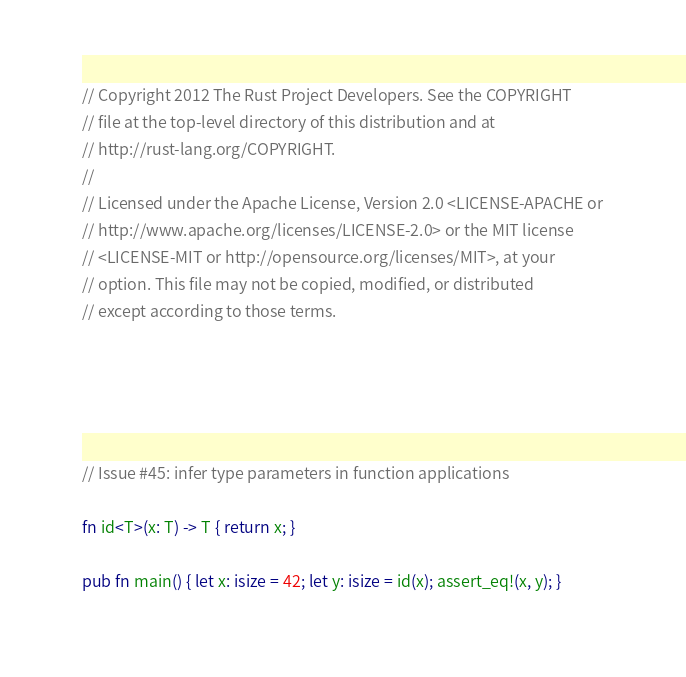<code> <loc_0><loc_0><loc_500><loc_500><_Rust_>// Copyright 2012 The Rust Project Developers. See the COPYRIGHT
// file at the top-level directory of this distribution and at
// http://rust-lang.org/COPYRIGHT.
//
// Licensed under the Apache License, Version 2.0 <LICENSE-APACHE or
// http://www.apache.org/licenses/LICENSE-2.0> or the MIT license
// <LICENSE-MIT or http://opensource.org/licenses/MIT>, at your
// option. This file may not be copied, modified, or distributed
// except according to those terms.





// Issue #45: infer type parameters in function applications

fn id<T>(x: T) -> T { return x; }

pub fn main() { let x: isize = 42; let y: isize = id(x); assert_eq!(x, y); }
</code> 